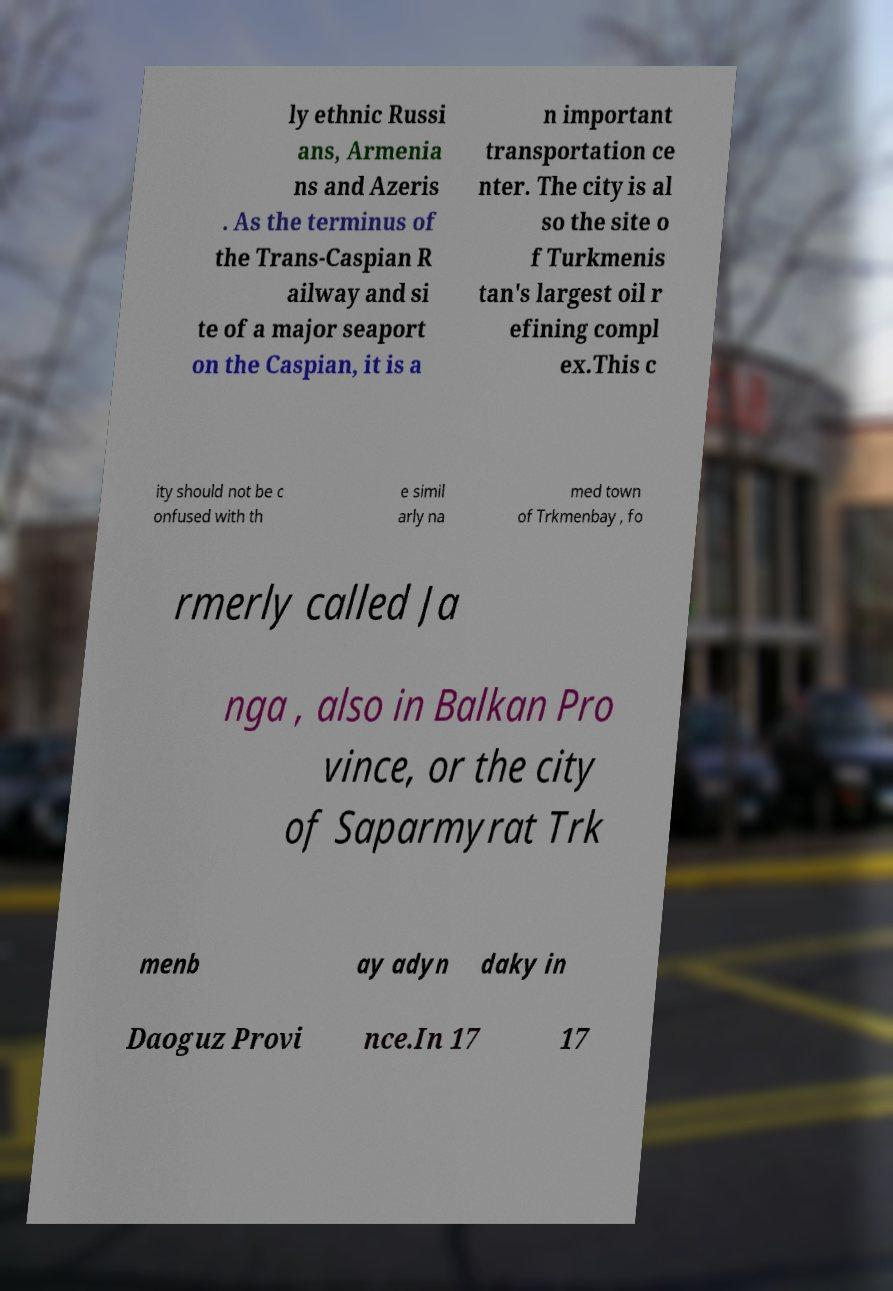Could you extract and type out the text from this image? ly ethnic Russi ans, Armenia ns and Azeris . As the terminus of the Trans-Caspian R ailway and si te of a major seaport on the Caspian, it is a n important transportation ce nter. The city is al so the site o f Turkmenis tan's largest oil r efining compl ex.This c ity should not be c onfused with th e simil arly na med town of Trkmenbay , fo rmerly called Ja nga , also in Balkan Pro vince, or the city of Saparmyrat Trk menb ay adyn daky in Daoguz Provi nce.In 17 17 